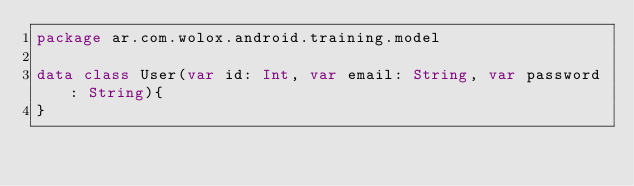Convert code to text. <code><loc_0><loc_0><loc_500><loc_500><_Kotlin_>package ar.com.wolox.android.training.model

data class User(var id: Int, var email: String, var password: String){
}
</code> 